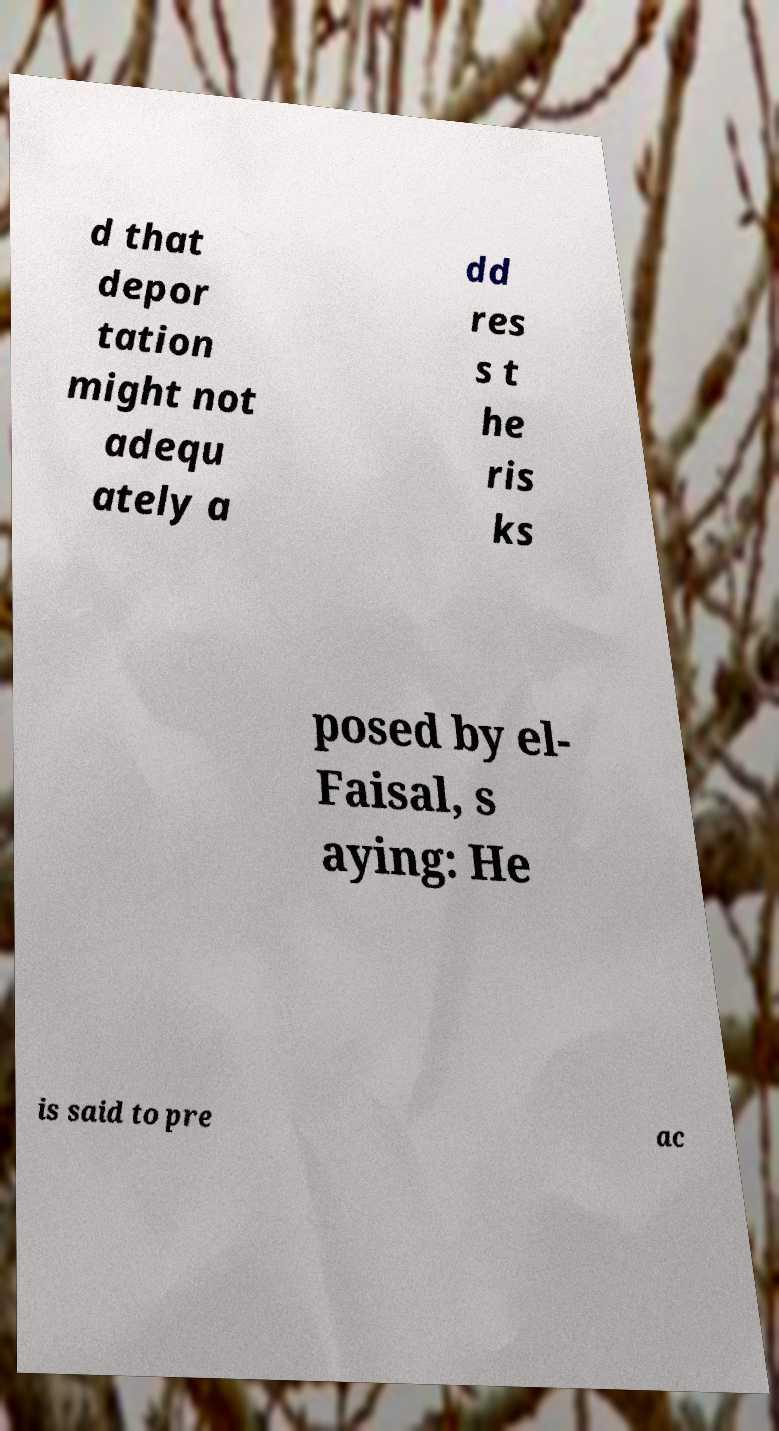I need the written content from this picture converted into text. Can you do that? d that depor tation might not adequ ately a dd res s t he ris ks posed by el- Faisal, s aying: He is said to pre ac 